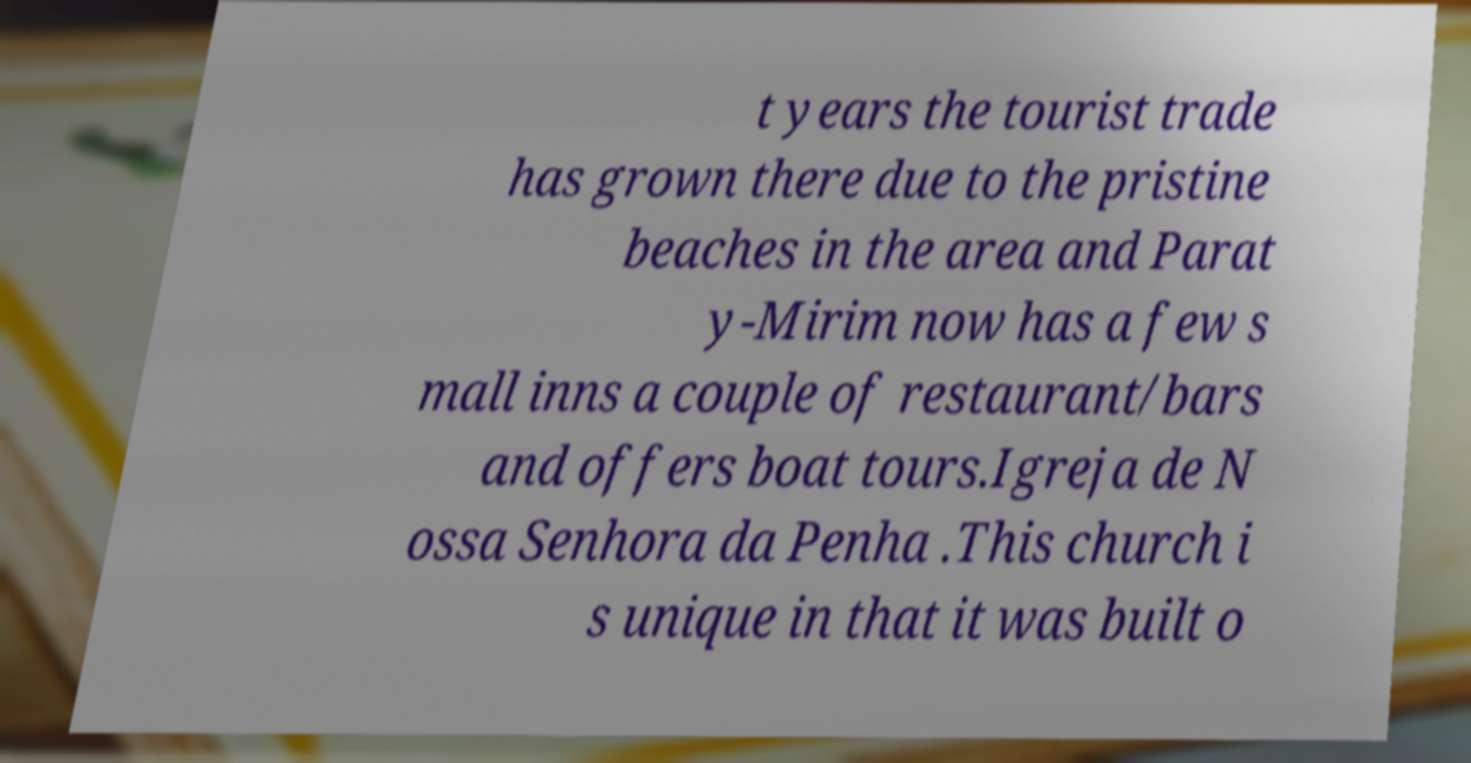Can you read and provide the text displayed in the image?This photo seems to have some interesting text. Can you extract and type it out for me? t years the tourist trade has grown there due to the pristine beaches in the area and Parat y-Mirim now has a few s mall inns a couple of restaurant/bars and offers boat tours.Igreja de N ossa Senhora da Penha .This church i s unique in that it was built o 